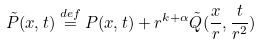Convert formula to latex. <formula><loc_0><loc_0><loc_500><loc_500>\tilde { P } ( x , t ) \overset { d e f } { = } P ( x , t ) + r ^ { k + \alpha } \tilde { Q } ( \frac { x } { r } , \frac { t } { r ^ { 2 } } )</formula> 